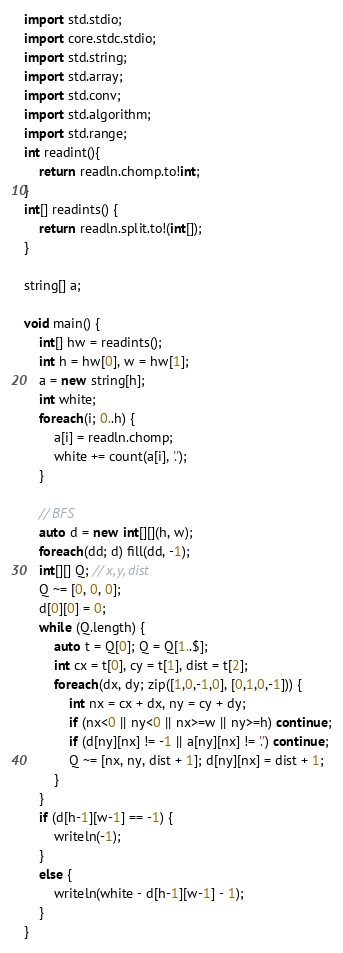<code> <loc_0><loc_0><loc_500><loc_500><_D_>import std.stdio;
import core.stdc.stdio;
import std.string;
import std.array;
import std.conv;
import std.algorithm;
import std.range;
int readint(){
    return readln.chomp.to!int;
}
int[] readints() {
    return readln.split.to!(int[]);
}

string[] a;

void main() {
    int[] hw = readints();
    int h = hw[0], w = hw[1];
    a = new string[h];
    int white;
    foreach(i; 0..h) {
        a[i] = readln.chomp;
        white += count(a[i], '.');
    }

    // BFS
    auto d = new int[][](h, w);
    foreach(dd; d) fill(dd, -1);
    int[][] Q; // x, y, dist
    Q ~= [0, 0, 0];
    d[0][0] = 0;
    while (Q.length) {
        auto t = Q[0]; Q = Q[1..$];
        int cx = t[0], cy = t[1], dist = t[2];
        foreach(dx, dy; zip([1,0,-1,0], [0,1,0,-1])) {
            int nx = cx + dx, ny = cy + dy;
            if (nx<0 || ny<0 || nx>=w || ny>=h) continue;
            if (d[ny][nx] != -1 || a[ny][nx] != '.') continue;
            Q ~= [nx, ny, dist + 1]; d[ny][nx] = dist + 1;
        }
    }
    if (d[h-1][w-1] == -1) {
        writeln(-1);
    }
    else {
        writeln(white - d[h-1][w-1] - 1);
    }
}</code> 